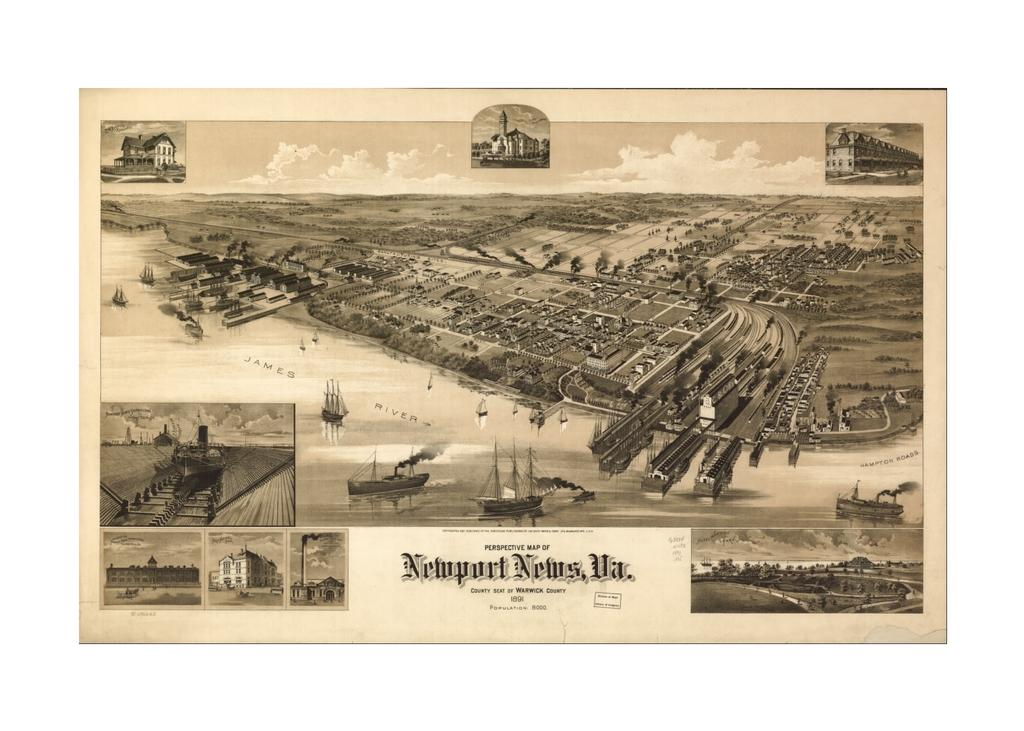<image>
Create a compact narrative representing the image presented. An old poster of a beachfront area, printed by newport News 